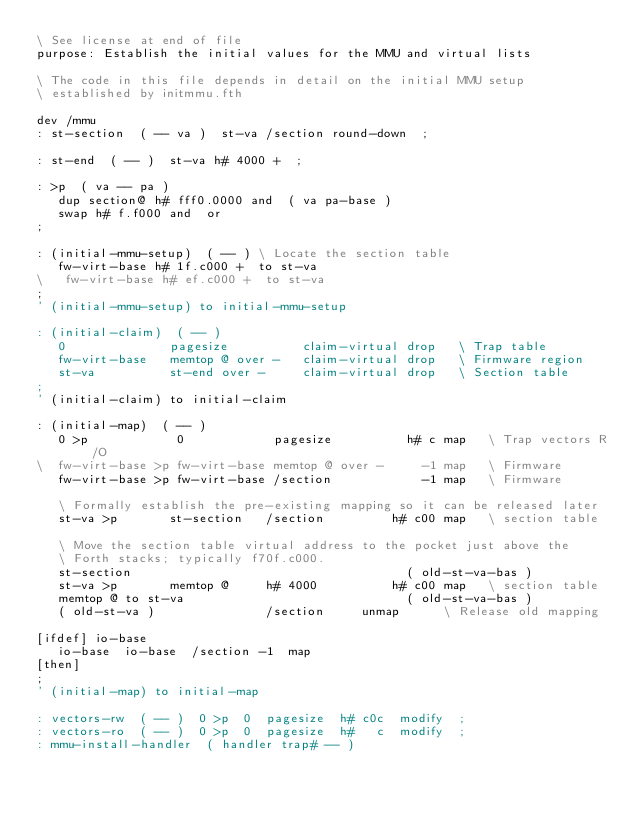<code> <loc_0><loc_0><loc_500><loc_500><_Forth_>\ See license at end of file
purpose: Establish the initial values for the MMU and virtual lists

\ The code in this file depends in detail on the initial MMU setup
\ established by initmmu.fth

dev /mmu
: st-section  ( -- va )  st-va /section round-down  ;

: st-end  ( -- )  st-va h# 4000 +  ;

: >p  ( va -- pa )
   dup section@ h# fff0.0000 and  ( va pa-base )
   swap h# f.f000 and  or
;

: (initial-mmu-setup)  ( -- )	\ Locate the section table
   fw-virt-base h# 1f.c000 +  to st-va
\   fw-virt-base h# ef.c000 +  to st-va
;
' (initial-mmu-setup) to initial-mmu-setup

: (initial-claim)  ( -- )
   0              pagesize          claim-virtual drop   \ Trap table
   fw-virt-base   memtop @ over -   claim-virtual drop   \ Firmware region
   st-va          st-end over -     claim-virtual drop   \ Section table
;
' (initial-claim) to initial-claim

: (initial-map)  ( -- )
   0 >p            0            pagesize          h# c map   \ Trap vectors R/O
\  fw-virt-base >p fw-virt-base memtop @ over -     -1 map   \ Firmware 
   fw-virt-base >p fw-virt-base /section            -1 map   \ Firmware 

   \ Formally establish the pre-existing mapping so it can be released later
   st-va >p       st-section   /section         h# c00 map   \ section table

   \ Move the section table virtual address to the pocket just above the
   \ Forth stacks; typically f70f.c000.
   st-section                                     ( old-st-va-bas )
   st-va >p       memtop @     h# 4000          h# c00 map   \ section table
   memtop @ to st-va                              ( old-st-va-bas )
   ( old-st-va )               /section     unmap   	 \ Release old mapping

[ifdef] io-base
   io-base  io-base  /section -1  map
[then]
;
' (initial-map) to initial-map

: vectors-rw  ( -- )  0 >p  0  pagesize  h# c0c  modify  ;
: vectors-ro  ( -- )  0 >p  0  pagesize  h#   c  modify  ;
: mmu-install-handler  ( handler trap# -- )</code> 